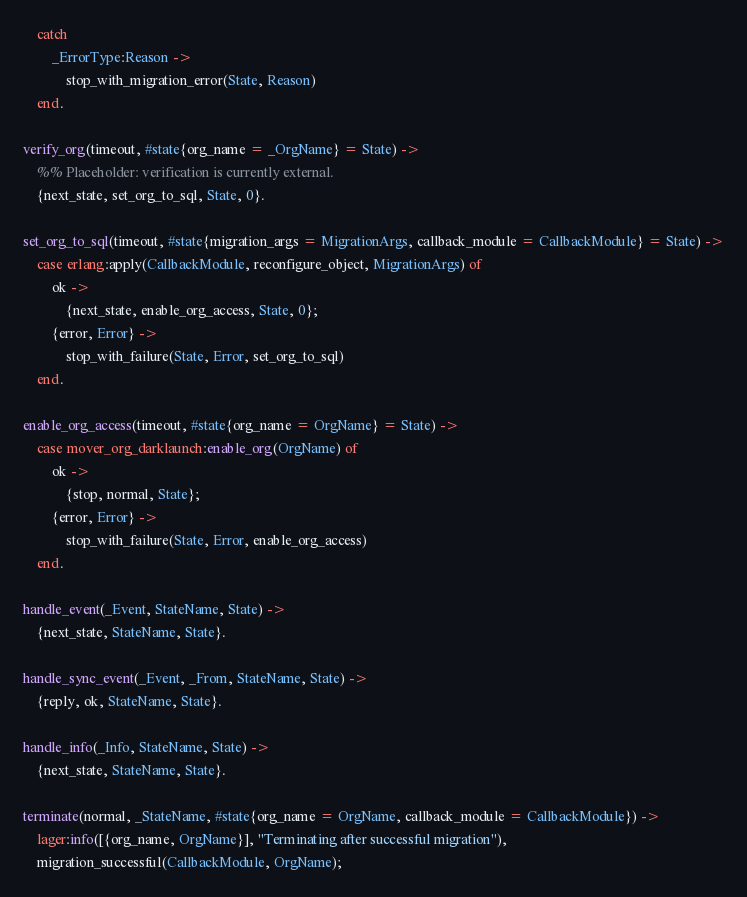Convert code to text. <code><loc_0><loc_0><loc_500><loc_500><_Erlang_>    catch
        _ErrorType:Reason ->
            stop_with_migration_error(State, Reason)
    end.

verify_org(timeout, #state{org_name = _OrgName} = State) ->
    %% Placeholder: verification is currently external.
    {next_state, set_org_to_sql, State, 0}.

set_org_to_sql(timeout, #state{migration_args = MigrationArgs, callback_module = CallbackModule} = State) ->
    case erlang:apply(CallbackModule, reconfigure_object, MigrationArgs) of
        ok ->
            {next_state, enable_org_access, State, 0};
        {error, Error} ->
            stop_with_failure(State, Error, set_org_to_sql)
    end.

enable_org_access(timeout, #state{org_name = OrgName} = State) ->
    case mover_org_darklaunch:enable_org(OrgName) of
        ok ->
            {stop, normal, State};
        {error, Error} ->
            stop_with_failure(State, Error, enable_org_access)
    end.

handle_event(_Event, StateName, State) ->
    {next_state, StateName, State}.

handle_sync_event(_Event, _From, StateName, State) ->
    {reply, ok, StateName, State}.

handle_info(_Info, StateName, State) ->
    {next_state, StateName, State}.

terminate(normal, _StateName, #state{org_name = OrgName, callback_module = CallbackModule}) ->
    lager:info([{org_name, OrgName}], "Terminating after successful migration"),
    migration_successful(CallbackModule, OrgName);</code> 